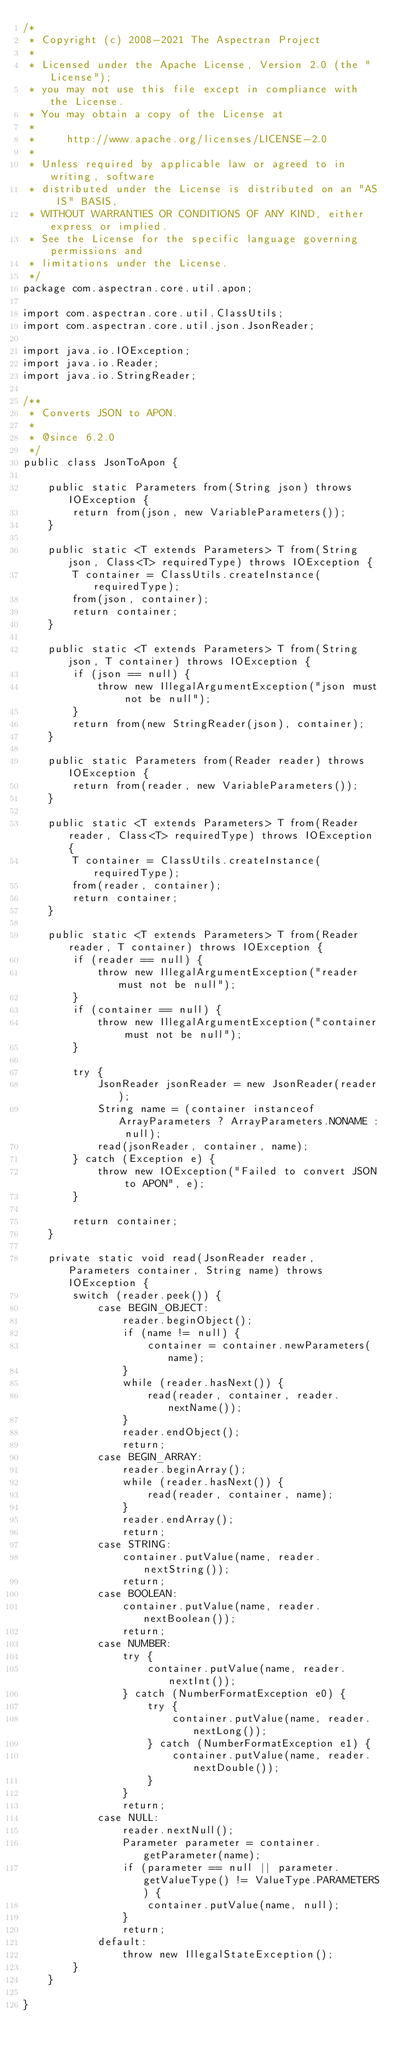<code> <loc_0><loc_0><loc_500><loc_500><_Java_>/*
 * Copyright (c) 2008-2021 The Aspectran Project
 *
 * Licensed under the Apache License, Version 2.0 (the "License");
 * you may not use this file except in compliance with the License.
 * You may obtain a copy of the License at
 *
 *     http://www.apache.org/licenses/LICENSE-2.0
 *
 * Unless required by applicable law or agreed to in writing, software
 * distributed under the License is distributed on an "AS IS" BASIS,
 * WITHOUT WARRANTIES OR CONDITIONS OF ANY KIND, either express or implied.
 * See the License for the specific language governing permissions and
 * limitations under the License.
 */
package com.aspectran.core.util.apon;

import com.aspectran.core.util.ClassUtils;
import com.aspectran.core.util.json.JsonReader;

import java.io.IOException;
import java.io.Reader;
import java.io.StringReader;

/**
 * Converts JSON to APON.
 *
 * @since 6.2.0
 */
public class JsonToApon {

    public static Parameters from(String json) throws IOException {
        return from(json, new VariableParameters());
    }

    public static <T extends Parameters> T from(String json, Class<T> requiredType) throws IOException {
        T container = ClassUtils.createInstance(requiredType);
        from(json, container);
        return container;
    }

    public static <T extends Parameters> T from(String json, T container) throws IOException {
        if (json == null) {
            throw new IllegalArgumentException("json must not be null");
        }
        return from(new StringReader(json), container);
    }

    public static Parameters from(Reader reader) throws IOException {
        return from(reader, new VariableParameters());
    }

    public static <T extends Parameters> T from(Reader reader, Class<T> requiredType) throws IOException {
        T container = ClassUtils.createInstance(requiredType);
        from(reader, container);
        return container;
    }

    public static <T extends Parameters> T from(Reader reader, T container) throws IOException {
        if (reader == null) {
            throw new IllegalArgumentException("reader must not be null");
        }
        if (container == null) {
            throw new IllegalArgumentException("container must not be null");
        }

        try {
            JsonReader jsonReader = new JsonReader(reader);
            String name = (container instanceof ArrayParameters ? ArrayParameters.NONAME : null);
            read(jsonReader, container, name);
        } catch (Exception e) {
            throw new IOException("Failed to convert JSON to APON", e);
        }

        return container;
    }

    private static void read(JsonReader reader, Parameters container, String name) throws IOException {
        switch (reader.peek()) {
            case BEGIN_OBJECT:
                reader.beginObject();
                if (name != null) {
                    container = container.newParameters(name);
                }
                while (reader.hasNext()) {
                    read(reader, container, reader.nextName());
                }
                reader.endObject();
                return;
            case BEGIN_ARRAY:
                reader.beginArray();
                while (reader.hasNext()) {
                    read(reader, container, name);
                }
                reader.endArray();
                return;
            case STRING:
                container.putValue(name, reader.nextString());
                return;
            case BOOLEAN:
                container.putValue(name, reader.nextBoolean());
                return;
            case NUMBER:
                try {
                    container.putValue(name, reader.nextInt());
                } catch (NumberFormatException e0) {
                    try {
                        container.putValue(name, reader.nextLong());
                    } catch (NumberFormatException e1) {
                        container.putValue(name, reader.nextDouble());
                    }
                }
                return;
            case NULL:
                reader.nextNull();
                Parameter parameter = container.getParameter(name);
                if (parameter == null || parameter.getValueType() != ValueType.PARAMETERS) {
                    container.putValue(name, null);
                }
                return;
            default:
                throw new IllegalStateException();
        }
    }

}
</code> 